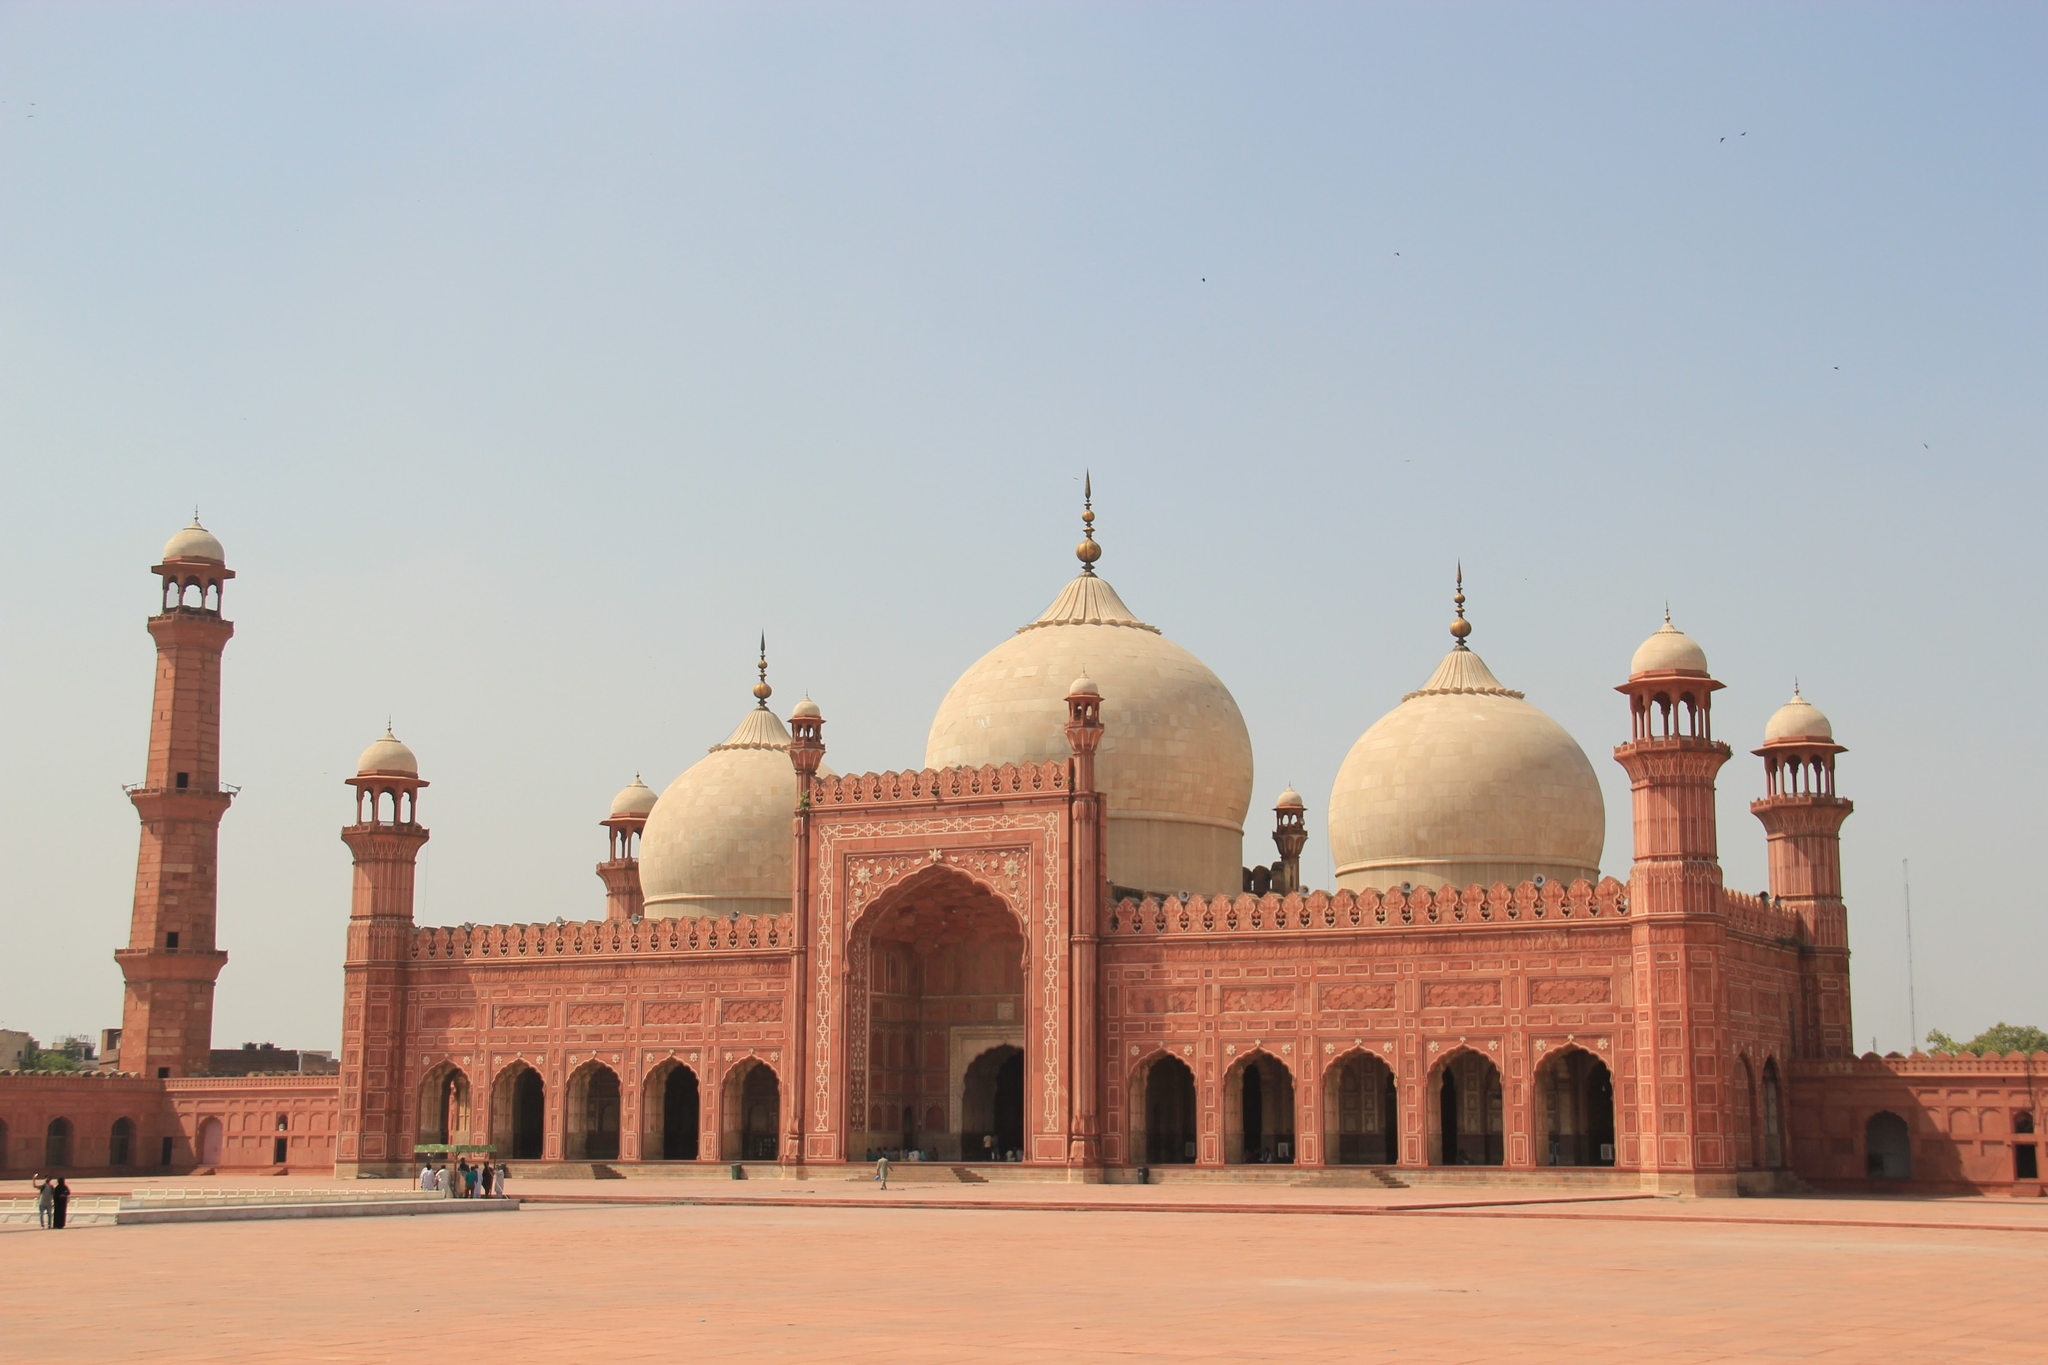What are the key elements in this picture?
 The image captures the majestic Badshahi Mosque in Lahore, Pakistan. Constructed from red sandstone, the mosque stands as a testament to the architectural prowess of the Mughal era. The mosque is adorned with three white marble domes that glisten under the clear blue sky. Flanking the mosque are two towering minarets that reach towards the heavens. The image is taken from a distance, allowing for a full view of the mosque in all its grandeur. A few birds can be seen soaring in the sky, adding a touch of life to the serene scene. In the foreground, blurred figures of people can be seen, indicating the mosque's role as a bustling center of community and faith. The image beautifully encapsulates the essence of this historic landmark. 